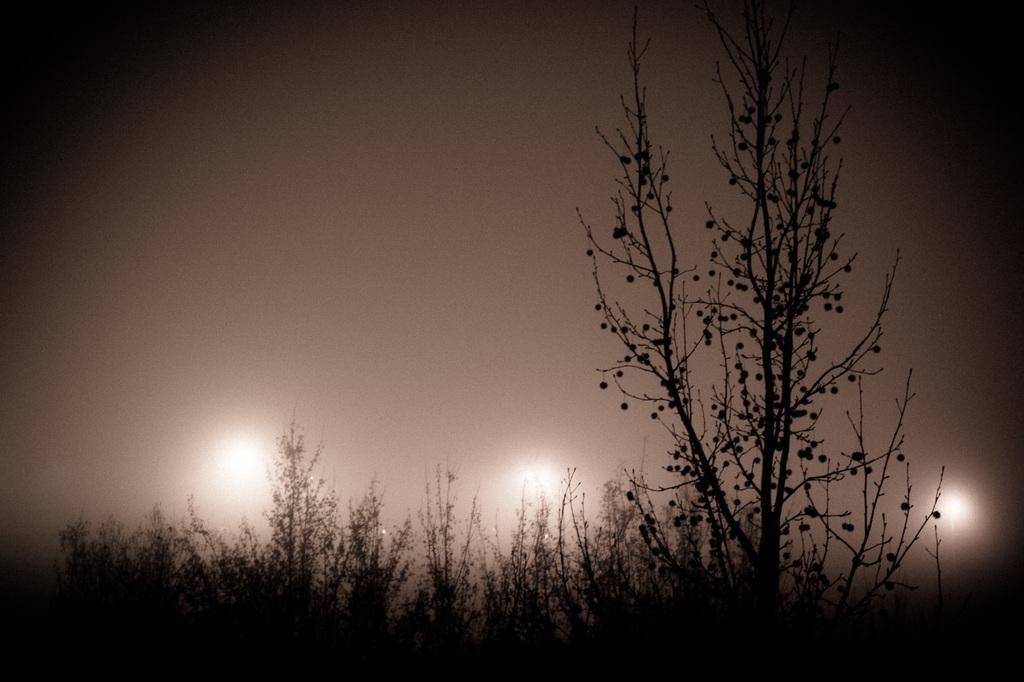How would you summarize this image in a sentence or two? In this image we can see plants, trees, lights and sky. 